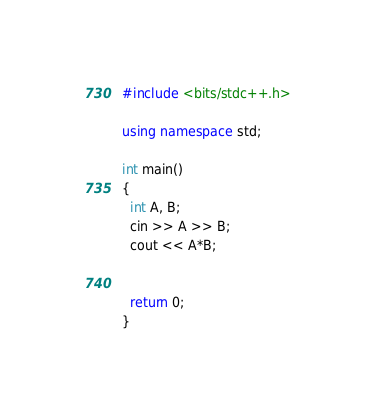<code> <loc_0><loc_0><loc_500><loc_500><_C++_>#include <bits/stdc++.h>

using namespace std;

int main()
{
  int A, B;
  cin >> A >> B;
  cout << A*B;
  
  
  return 0;
}</code> 